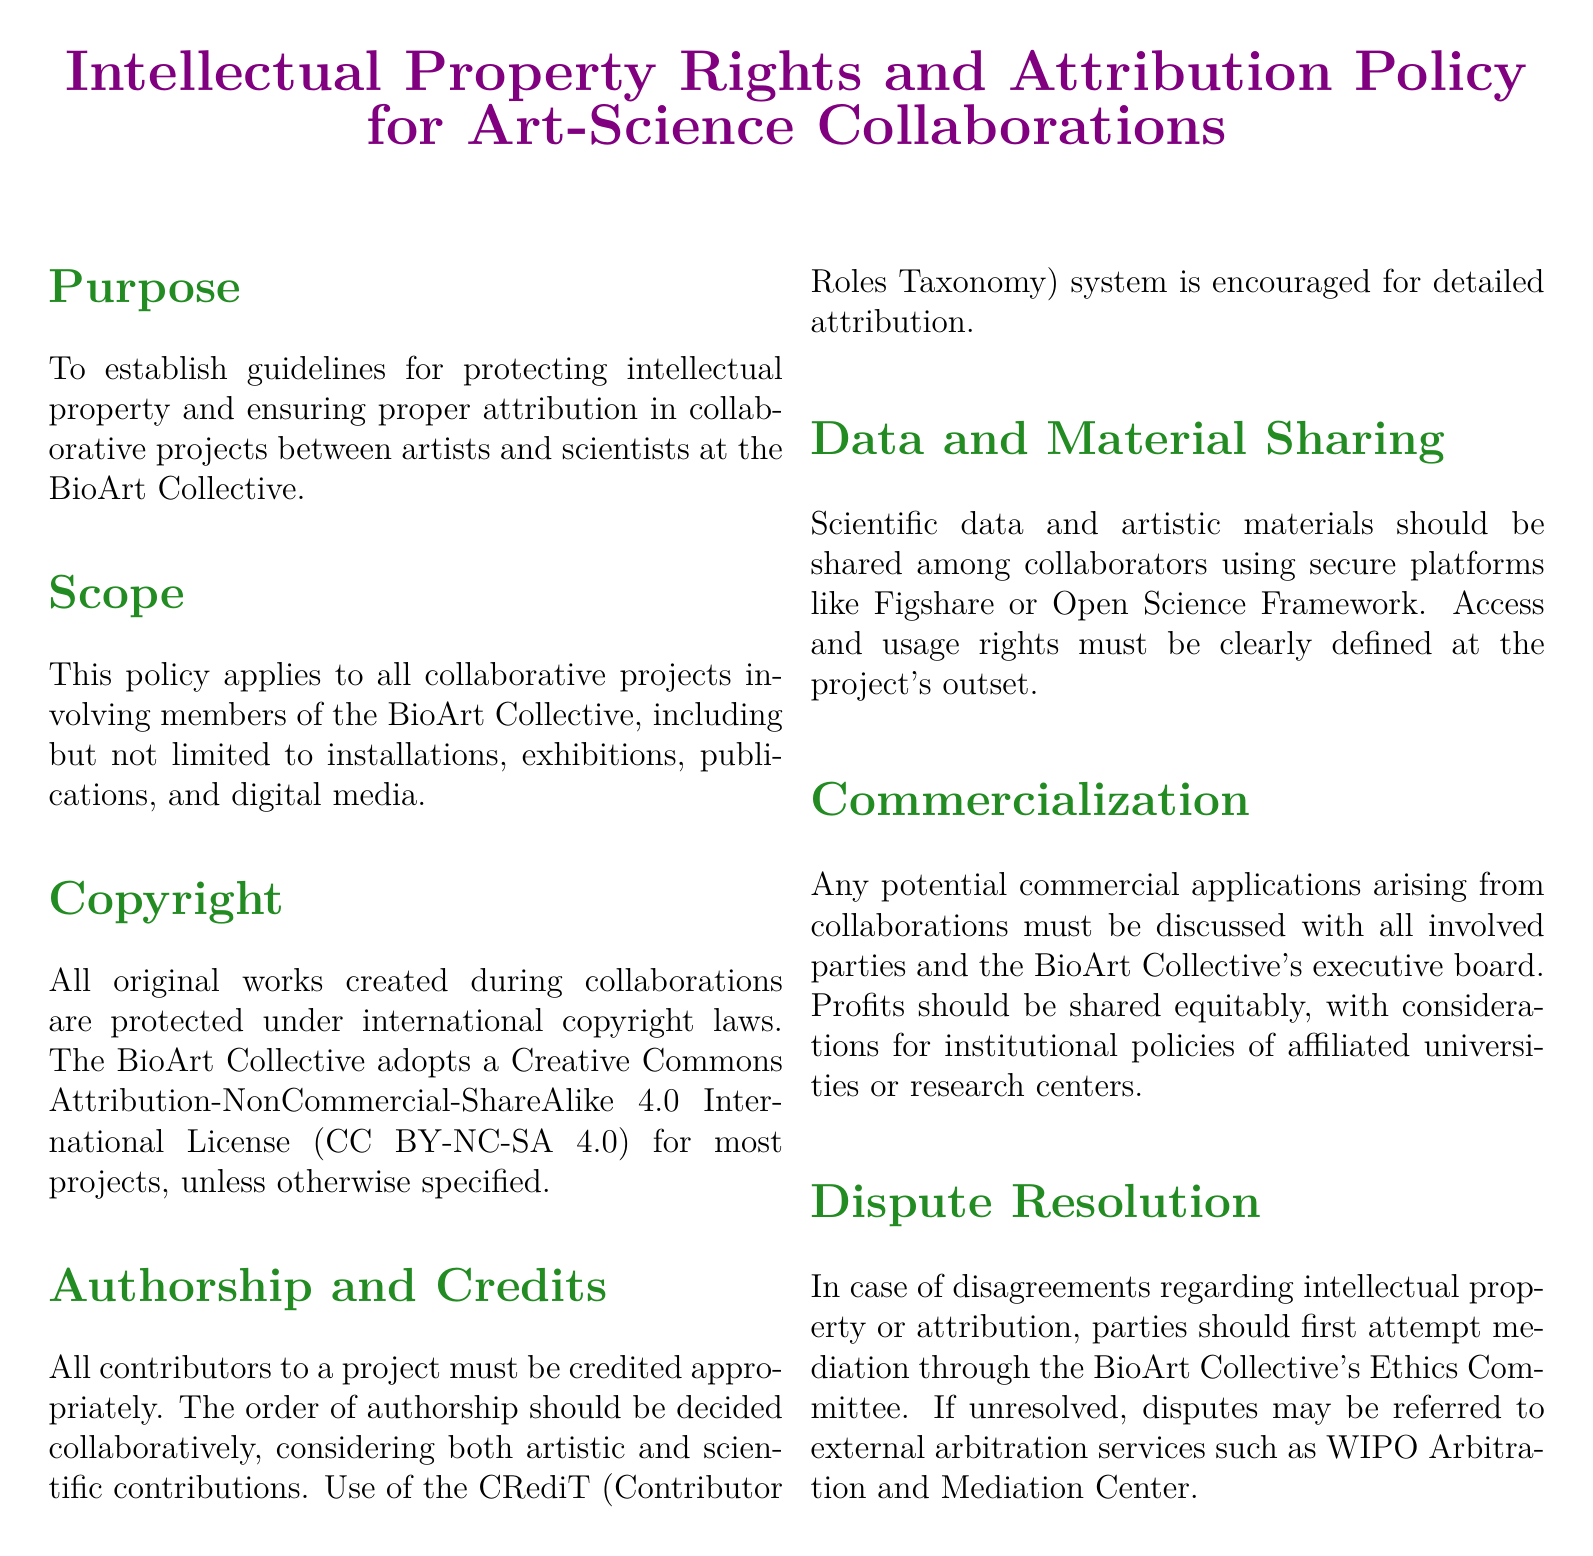What is the title of the document? The title of the document is stated in the center and emphasizes the main focus of the content.
Answer: Intellectual Property Rights and Attribution Policy for Art-Science Collaborations Who does this policy apply to? The policy specifies that it applies to a specific group involved in collaborative projects, indicating its intended audience.
Answer: members of the BioArt Collective What license does the BioArt Collective adopt for most projects? The document states the type of license applicable to most projects, which defines how works can be shared and reused.
Answer: Creative Commons Attribution-NonCommercial-ShareAlike 4.0 International License What system is encouraged for detailed attribution? The policy mentions a specific system that helps in recognizing all contributions to a project, which is a standard approach in collaborative works.
Answer: CRediT (Contributor Roles Taxonomy) What should be discussed concerning commercialization? This question concerns the requirements for any commercial endeavors that might arise from collaborations, pointing to necessary actions first before proceeding.
Answer: discussed with all involved parties and the BioArt Collective's executive board What is the first step in case of a dispute? The document provides a guideline for resolving disagreements regarding intellectual property, indicating the initial approach to take in such situations.
Answer: mediation through the BioArt Collective's Ethics Committee 